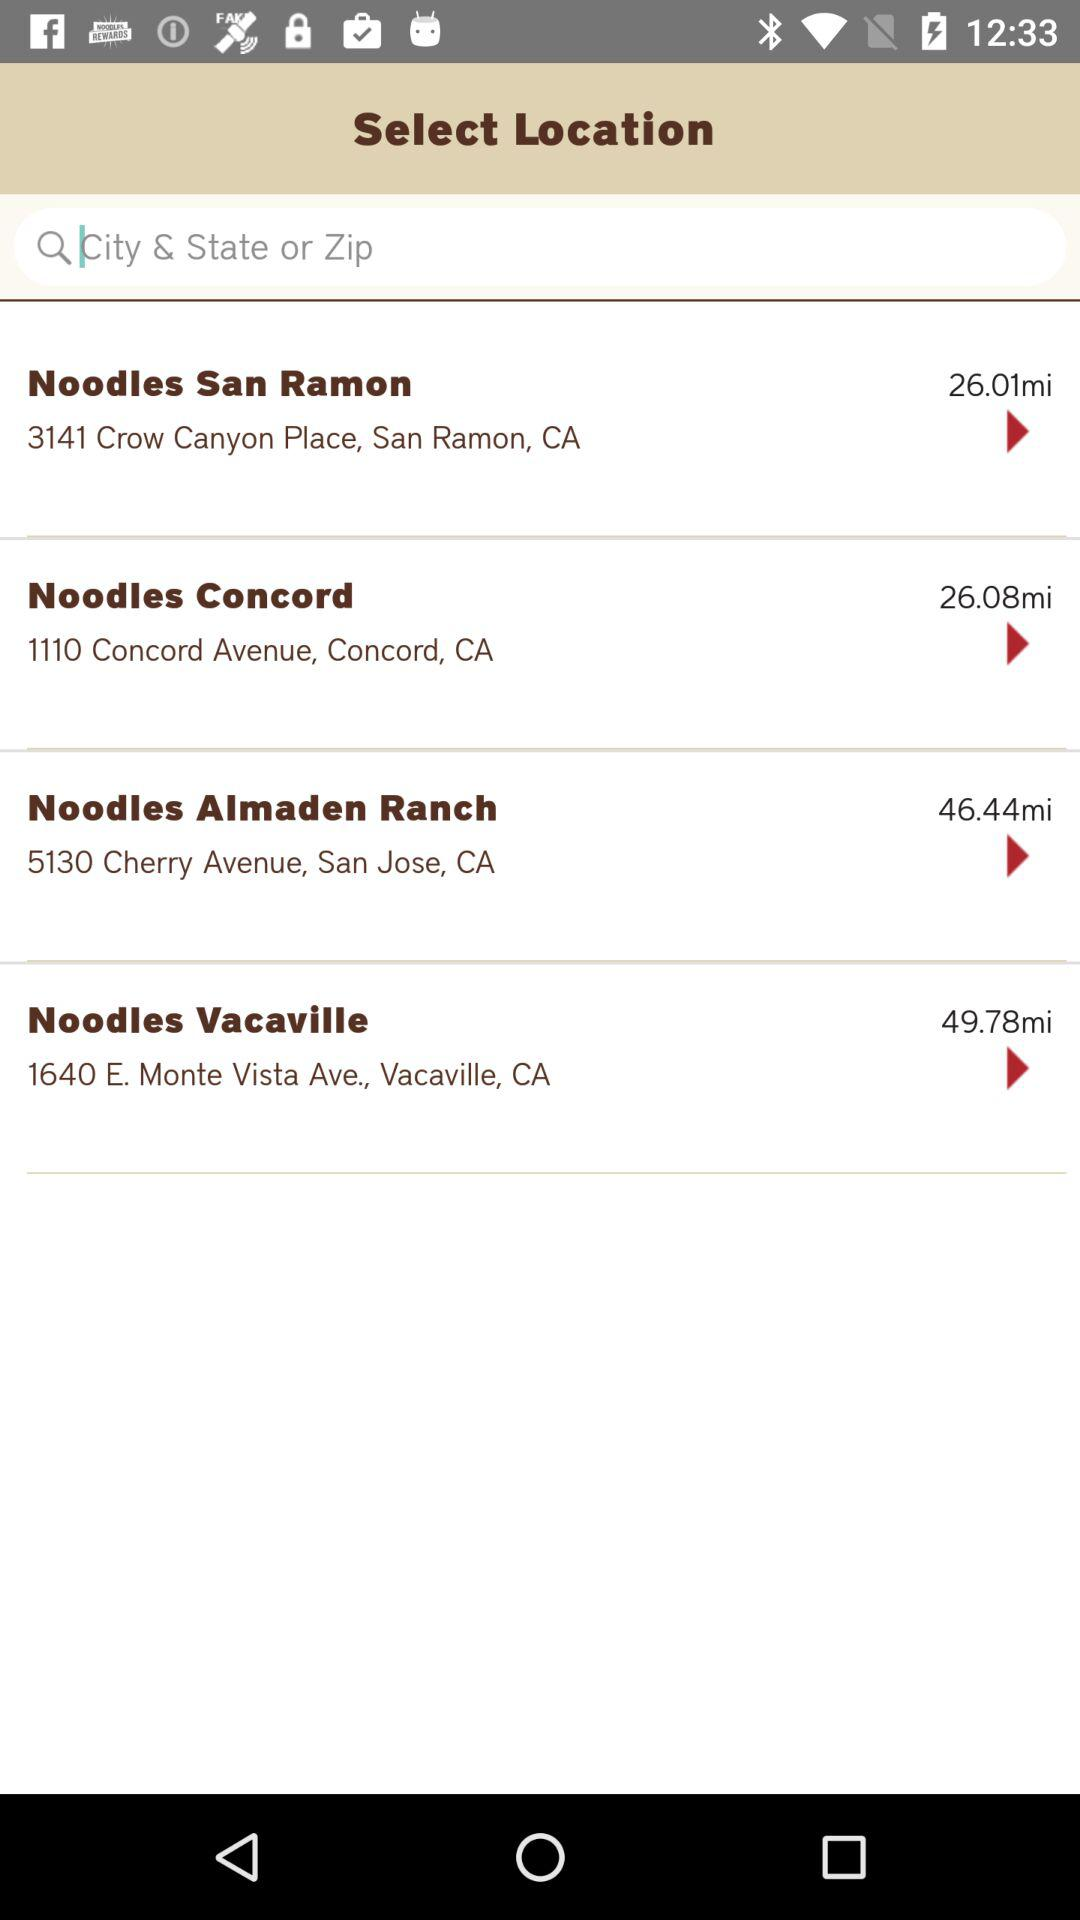How many miles is the furthest Noodles restaurant from the user?
Answer the question using a single word or phrase. 49.78 